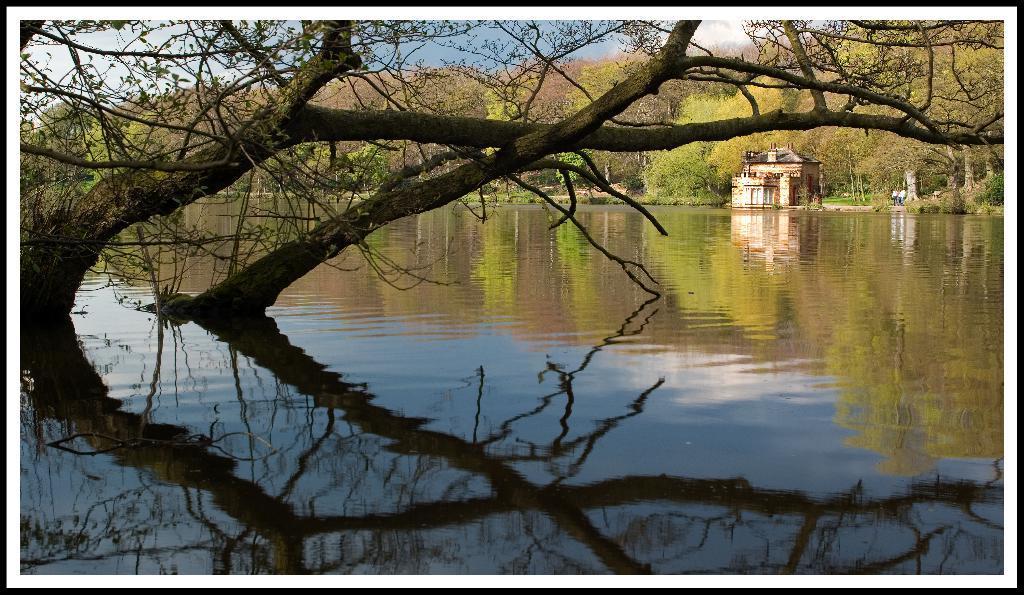Can you describe this image briefly? In this picture I can see trees and a building and I can see water and a blue cloudy sky. 